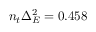Convert formula to latex. <formula><loc_0><loc_0><loc_500><loc_500>n _ { t } \Delta _ { E } ^ { 2 } = 0 . 4 5 8</formula> 